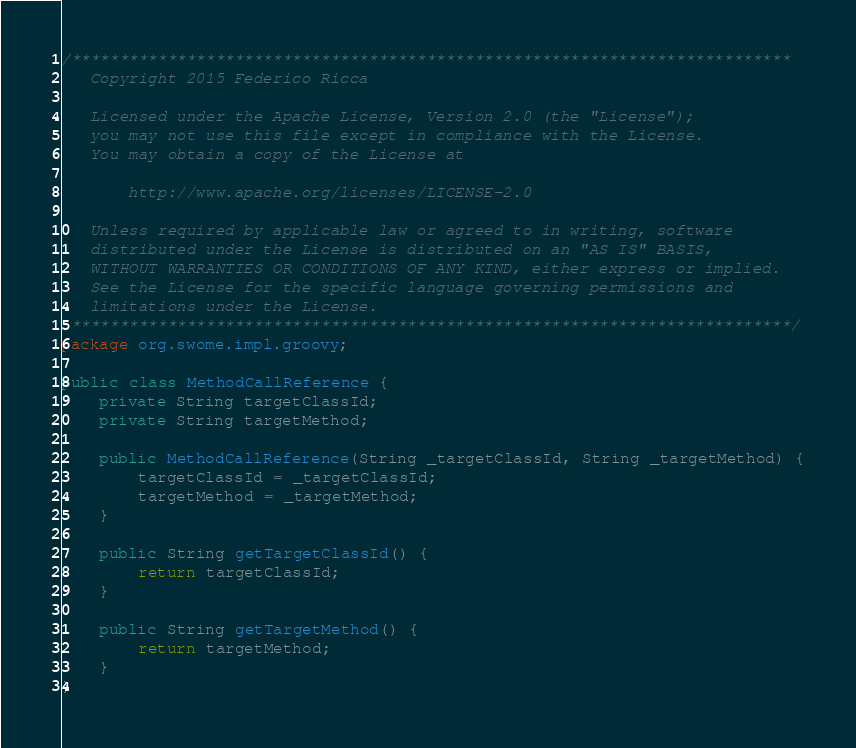<code> <loc_0><loc_0><loc_500><loc_500><_Java_>/*************************************************************************** 
   Copyright 2015 Federico Ricca

   Licensed under the Apache License, Version 2.0 (the "License");
   you may not use this file except in compliance with the License.
   You may obtain a copy of the License at

       http://www.apache.org/licenses/LICENSE-2.0

   Unless required by applicable law or agreed to in writing, software
   distributed under the License is distributed on an "AS IS" BASIS,
   WITHOUT WARRANTIES OR CONDITIONS OF ANY KIND, either express or implied.
   See the License for the specific language governing permissions and
   limitations under the License.
 ***************************************************************************/
package org.swome.impl.groovy;

public class MethodCallReference {
	private String targetClassId;
	private String targetMethod;

	public MethodCallReference(String _targetClassId, String _targetMethod) {
		targetClassId = _targetClassId;
		targetMethod = _targetMethod;
	}

	public String getTargetClassId() {
		return targetClassId;
	}

	public String getTargetMethod() {
		return targetMethod;
	}
}
</code> 